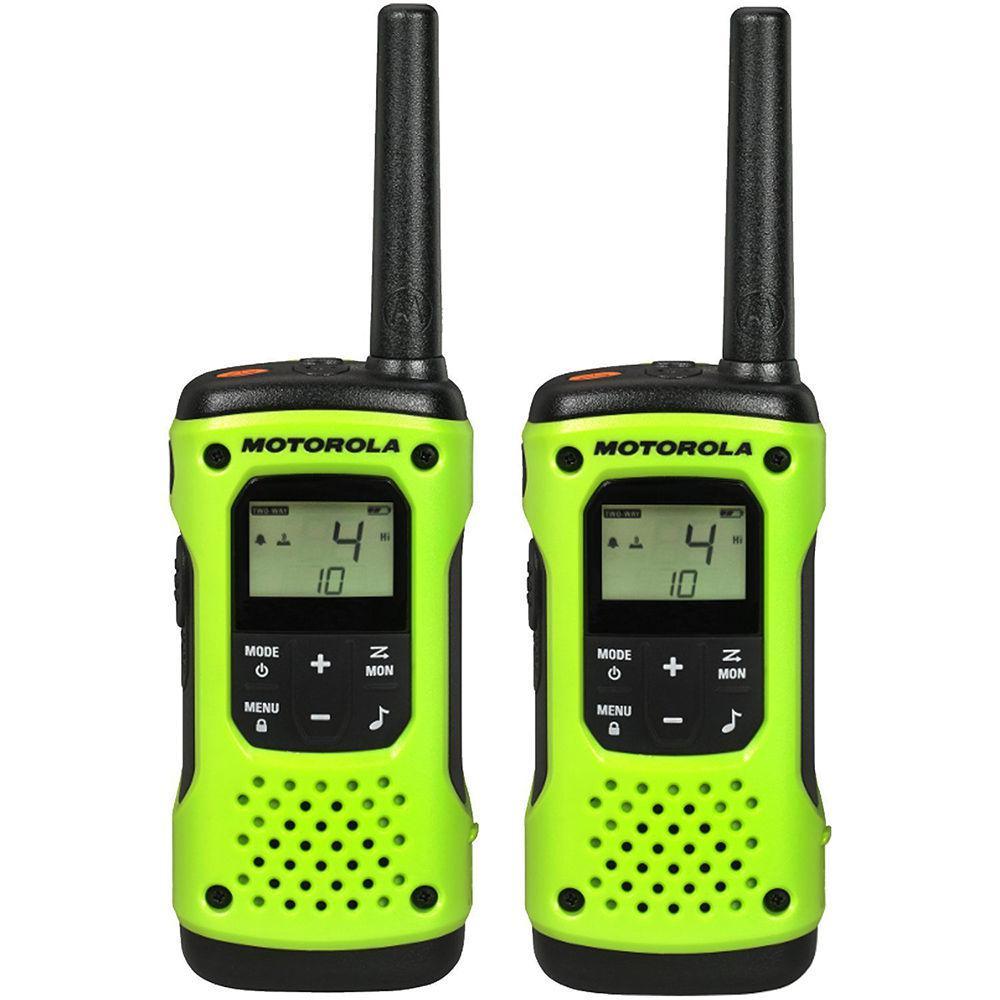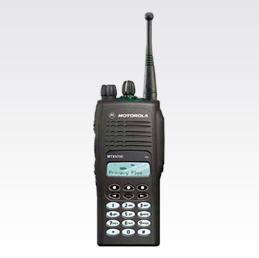The first image is the image on the left, the second image is the image on the right. Assess this claim about the two images: "There are three walkie talkies.". Correct or not? Answer yes or no. Yes. The first image is the image on the left, the second image is the image on the right. For the images displayed, is the sentence "At least 3 walkie-talkies are lined up next to each other in each picture." factually correct? Answer yes or no. No. 